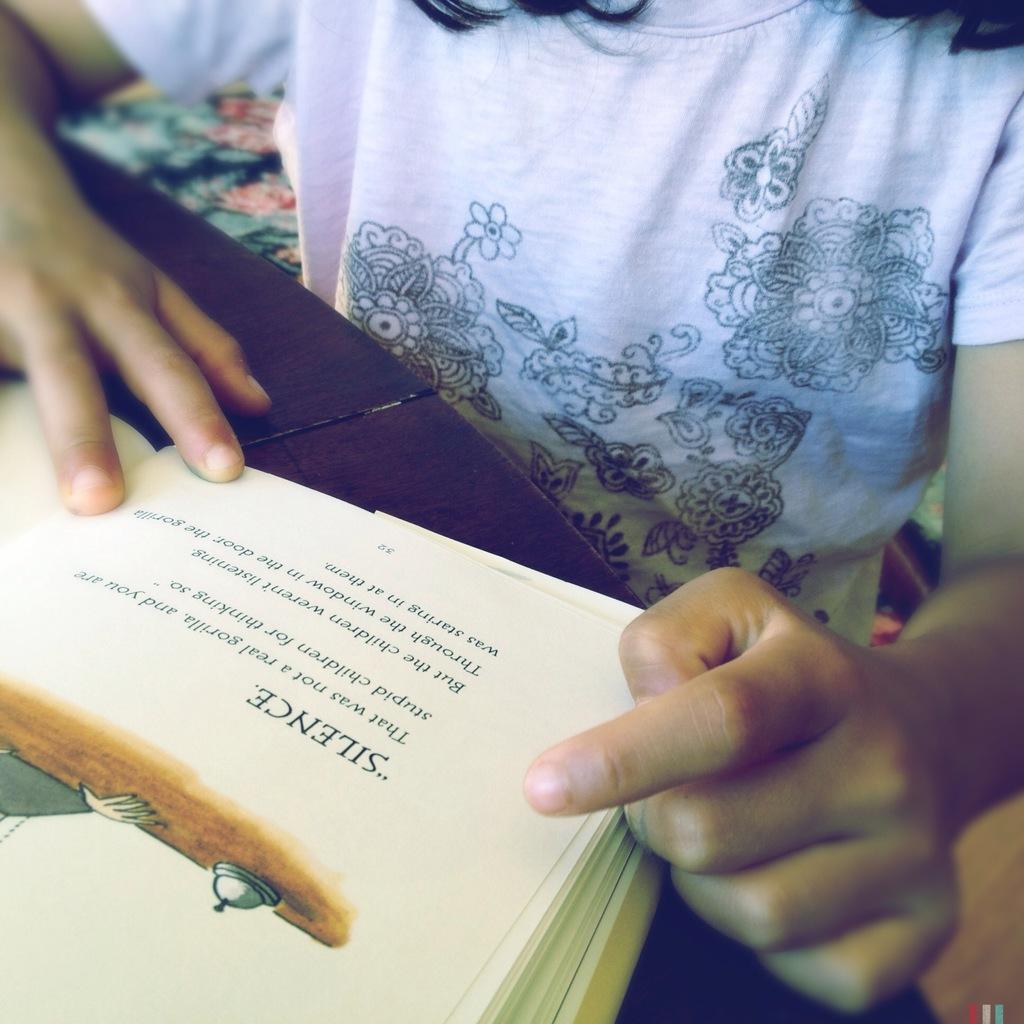What is that say in the book?
Keep it short and to the point. Silence. What word is the child pointing at?
Offer a terse response. Silence. 